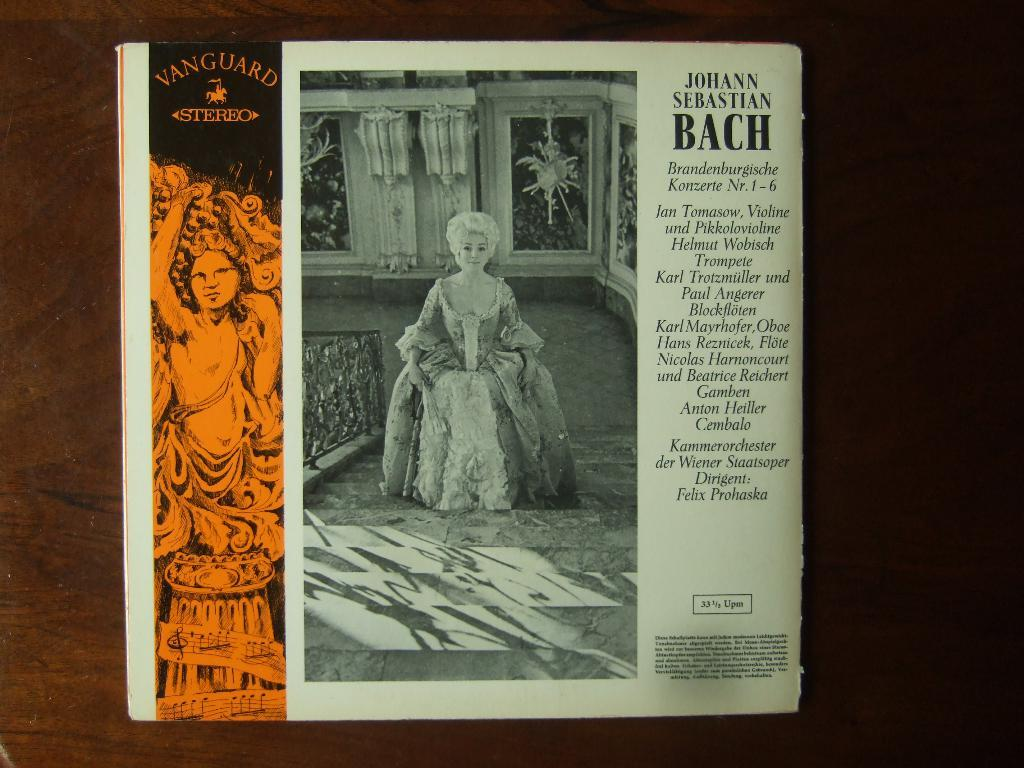<image>
Render a clear and concise summary of the photo. The back of a box or record label of Johann Sebastian Bach. 